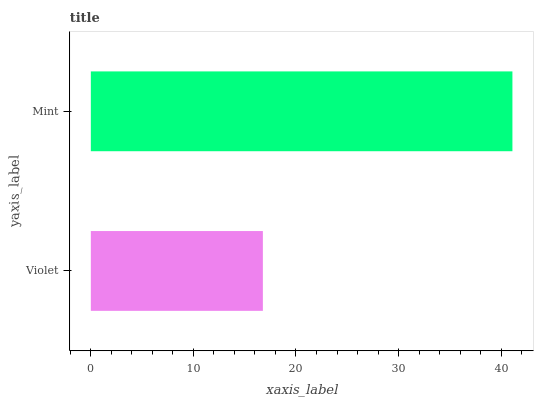Is Violet the minimum?
Answer yes or no. Yes. Is Mint the maximum?
Answer yes or no. Yes. Is Mint the minimum?
Answer yes or no. No. Is Mint greater than Violet?
Answer yes or no. Yes. Is Violet less than Mint?
Answer yes or no. Yes. Is Violet greater than Mint?
Answer yes or no. No. Is Mint less than Violet?
Answer yes or no. No. Is Mint the high median?
Answer yes or no. Yes. Is Violet the low median?
Answer yes or no. Yes. Is Violet the high median?
Answer yes or no. No. Is Mint the low median?
Answer yes or no. No. 